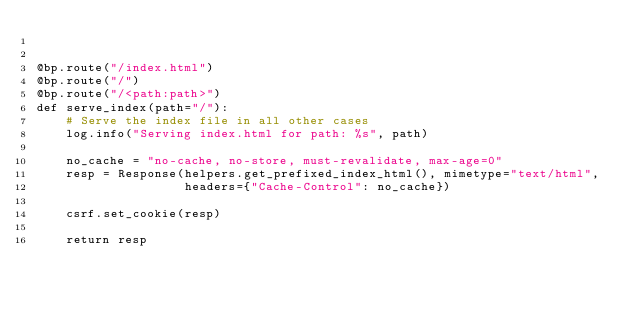<code> <loc_0><loc_0><loc_500><loc_500><_Python_>

@bp.route("/index.html")
@bp.route("/")
@bp.route("/<path:path>")
def serve_index(path="/"):
    # Serve the index file in all other cases
    log.info("Serving index.html for path: %s", path)

    no_cache = "no-cache, no-store, must-revalidate, max-age=0"
    resp = Response(helpers.get_prefixed_index_html(), mimetype="text/html",
                    headers={"Cache-Control": no_cache})

    csrf.set_cookie(resp)

    return resp
</code> 